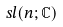<formula> <loc_0><loc_0><loc_500><loc_500>s l ( n ; \mathbb { C } )</formula> 